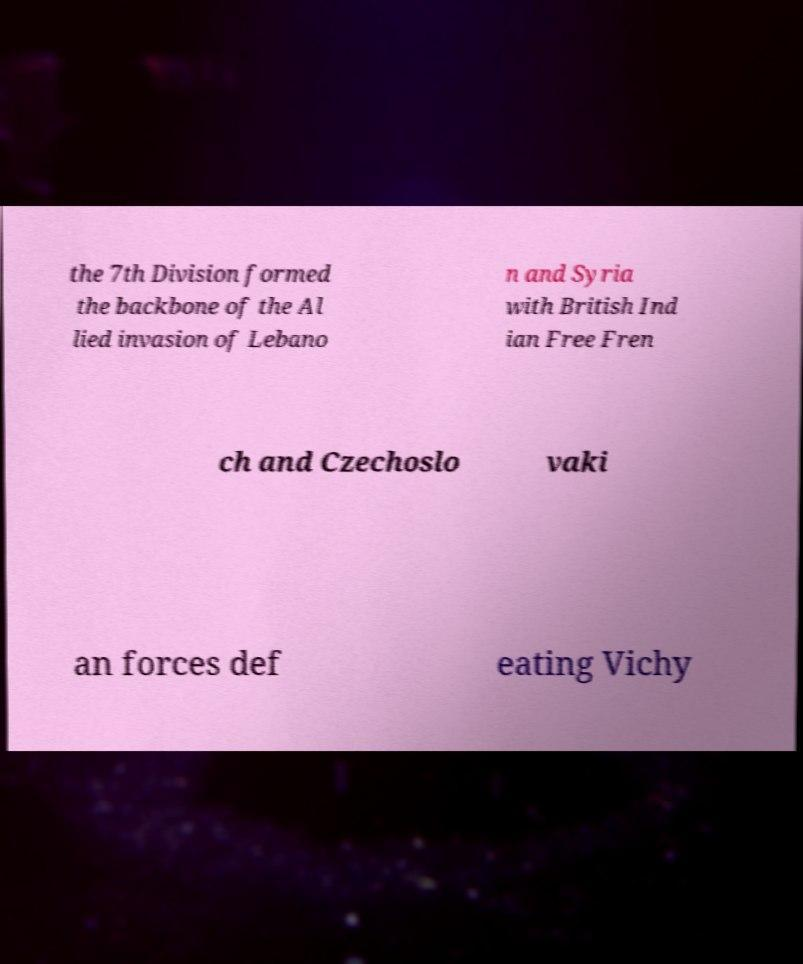Please read and relay the text visible in this image. What does it say? the 7th Division formed the backbone of the Al lied invasion of Lebano n and Syria with British Ind ian Free Fren ch and Czechoslo vaki an forces def eating Vichy 